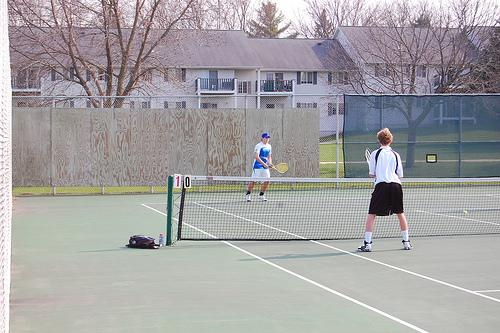Identify one accessory the boy is wearing to protect himself from the sun in the image. The boy is wearing a blue hat to protect his eyes from the sun. Can you identify any significant features about the fencing surrounding the tennis court? The fence has wooden boards attached to it and dark green net fencing. What are the colors of the tennis player's clothes? The tennis players are wearing black and white, and blue and white clothing. Explain the position of the tennis court in relation to other elements in the image. The tennis court is surrounded by a wooden fence, with trees and residential buildings in the background. Point out what the two men in the image are engaged in, and provide a description of their outfits. The two men are playing tennis. One is wearing black and white, while the other is wearing blue and white. Briefly mention three noticeable items in the image that are not directly related to tennis. An outdoor deck on a building, a water bottle, and residential buildings in the distance. How many players are participating, and what color hats do they wear? There are two tennis players, and one is wearing a blue hat. Describe the tennis court itself, including the surface and divider. The tennis court is green and white with a black and white tennis net dividing it. What type of court markings and boundaries can be seen in the image? There are white lines painted for boundaries, a black and white tennis net, and a net for boundaries. Describe the footwear and other details pertaining to the feet of one tennis player. The boy is wearing shoes, white socks, and black shorts. 